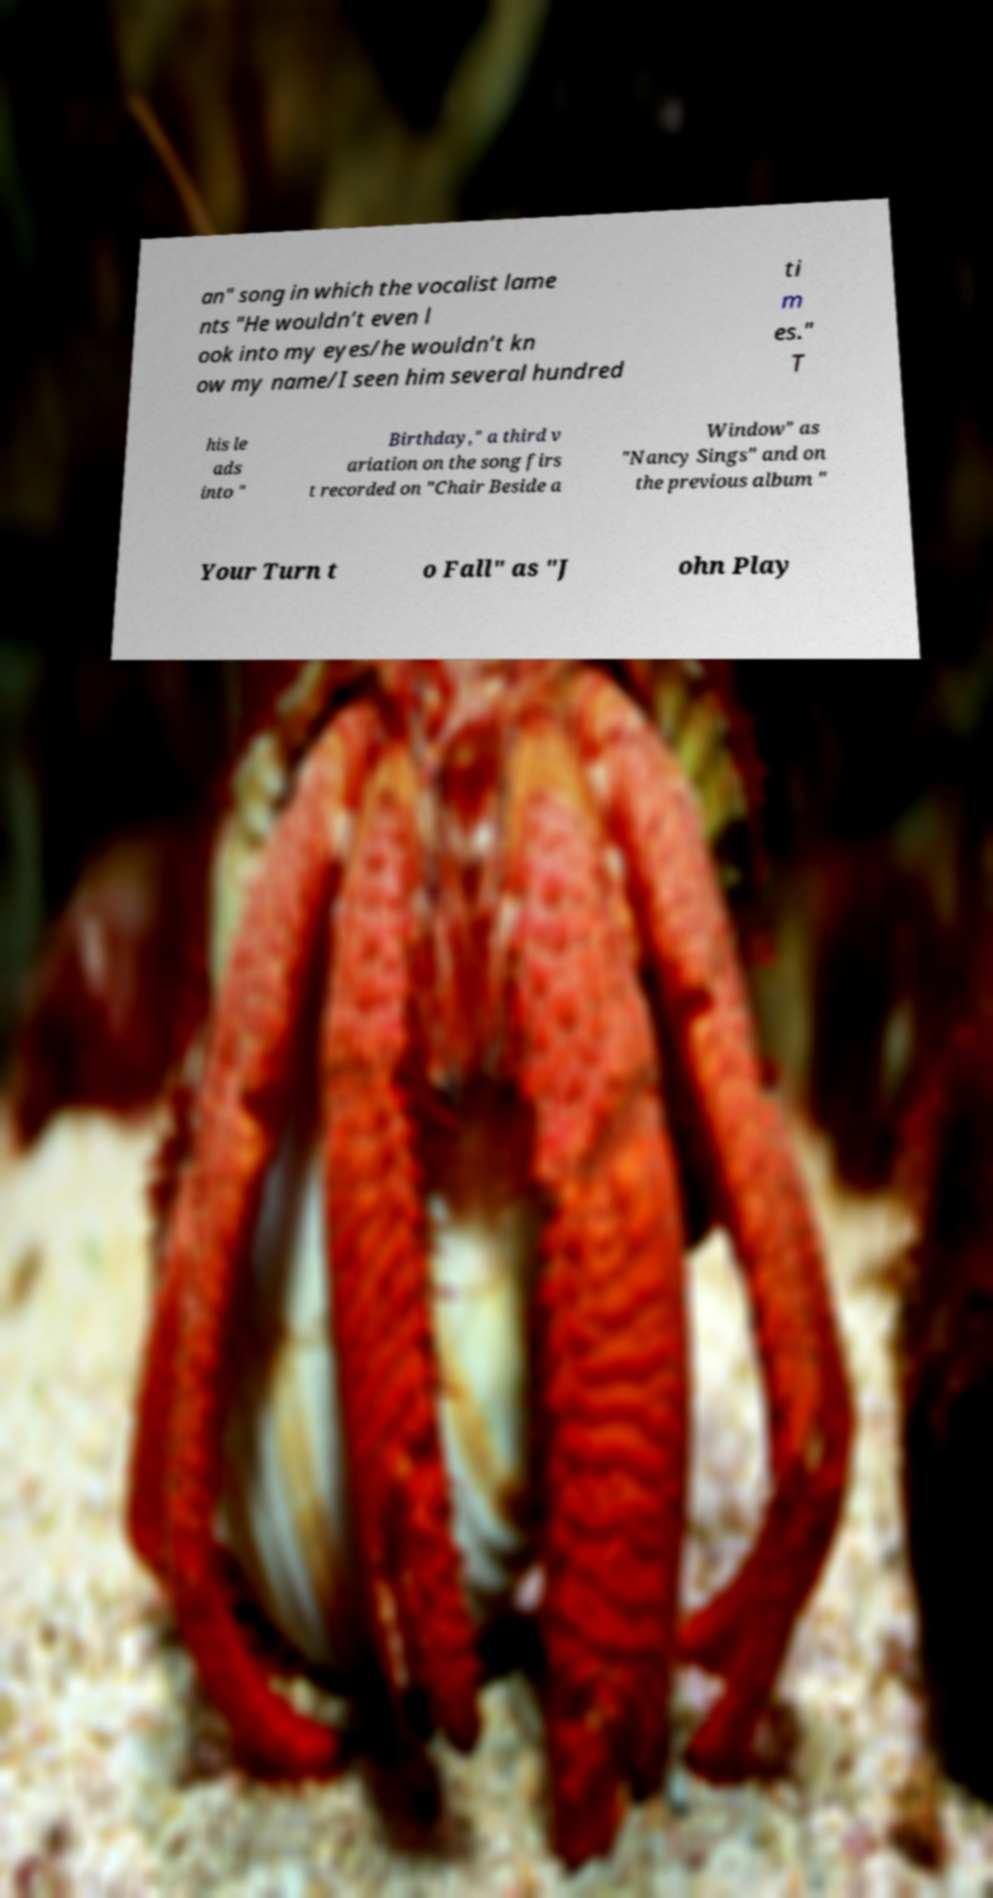Can you read and provide the text displayed in the image?This photo seems to have some interesting text. Can you extract and type it out for me? an" song in which the vocalist lame nts "He wouldn’t even l ook into my eyes/he wouldn’t kn ow my name/I seen him several hundred ti m es." T his le ads into " Birthday," a third v ariation on the song firs t recorded on "Chair Beside a Window" as "Nancy Sings" and on the previous album " Your Turn t o Fall" as "J ohn Play 